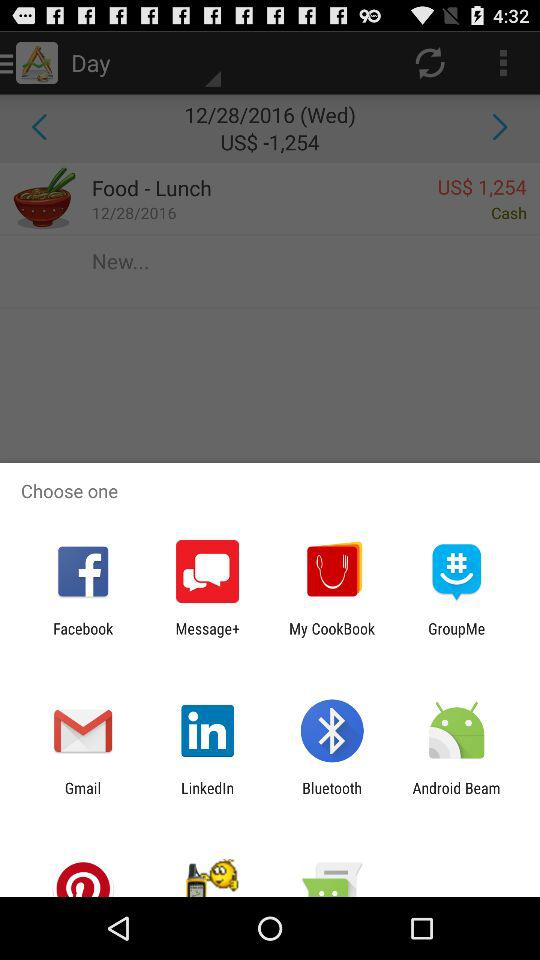Through which app can I share? You can share through "Facebook", "Message+", "My CookBook", "GroupMe", "Gmail", "Linkedin", "Bluetooth" and "Android Beam". 